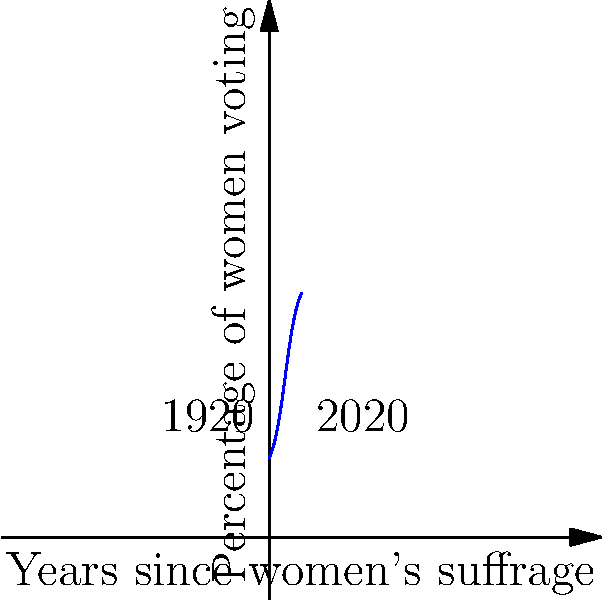The graph shows the percentage of women voting in Egypt over time since women's suffrage was granted. If the curve is modeled by the function $f(x) = 20 + \frac{60}{1+e^{-0.5(x-5)}}$, where $x$ represents the number of years since women's suffrage was granted, what is the rate of change in women's voting participation 5 years after suffrage was granted? To find the rate of change 5 years after suffrage was granted, we need to calculate the derivative of the function $f(x)$ and evaluate it at $x=5$.

Step 1: Calculate the derivative of $f(x)$.
$f(x) = 20 + \frac{60}{1+e^{-0.5(x-5)}}$
Let $u = 1+e^{-0.5(x-5)}$
$f'(x) = 0 + 60 \cdot \frac{d}{dx}(\frac{1}{u})$
$f'(x) = 60 \cdot (-\frac{1}{u^2}) \cdot \frac{du}{dx}$
$f'(x) = 60 \cdot (-\frac{1}{u^2}) \cdot (-0.5e^{-0.5(x-5)})$
$f'(x) = \frac{30e^{-0.5(x-5)}}{(1+e^{-0.5(x-5)})^2}$

Step 2: Evaluate $f'(x)$ at $x=5$.
$f'(5) = \frac{30e^{-0.5(5-5)}}{(1+e^{-0.5(5-5)})^2}$
$f'(5) = \frac{30e^0}{(1+e^0)^2}$
$f'(5) = \frac{30}{(1+1)^2}$
$f'(5) = \frac{30}{4} = 7.5$

Therefore, the rate of change in women's voting participation 5 years after suffrage was granted is 7.5% per year.
Answer: 7.5% per year 